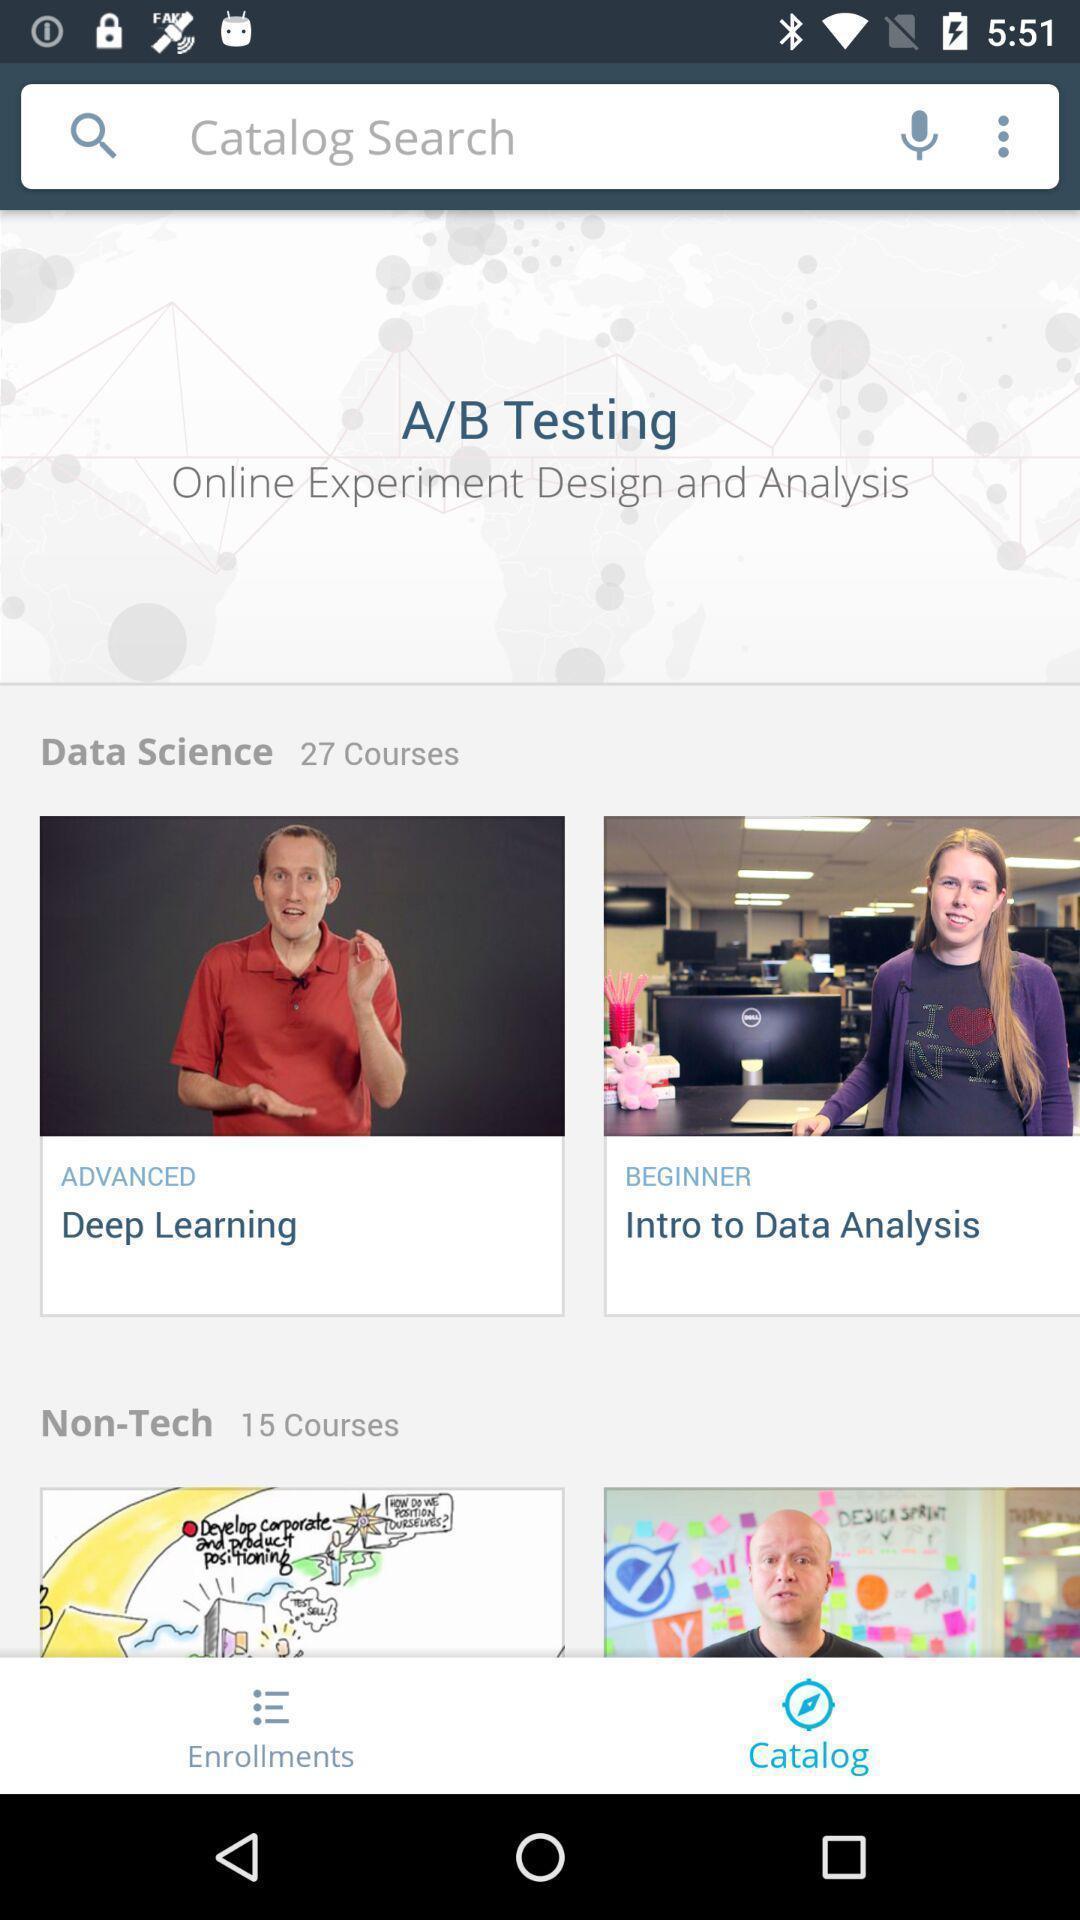Explain the elements present in this screenshot. Search page for searching a catalog. 